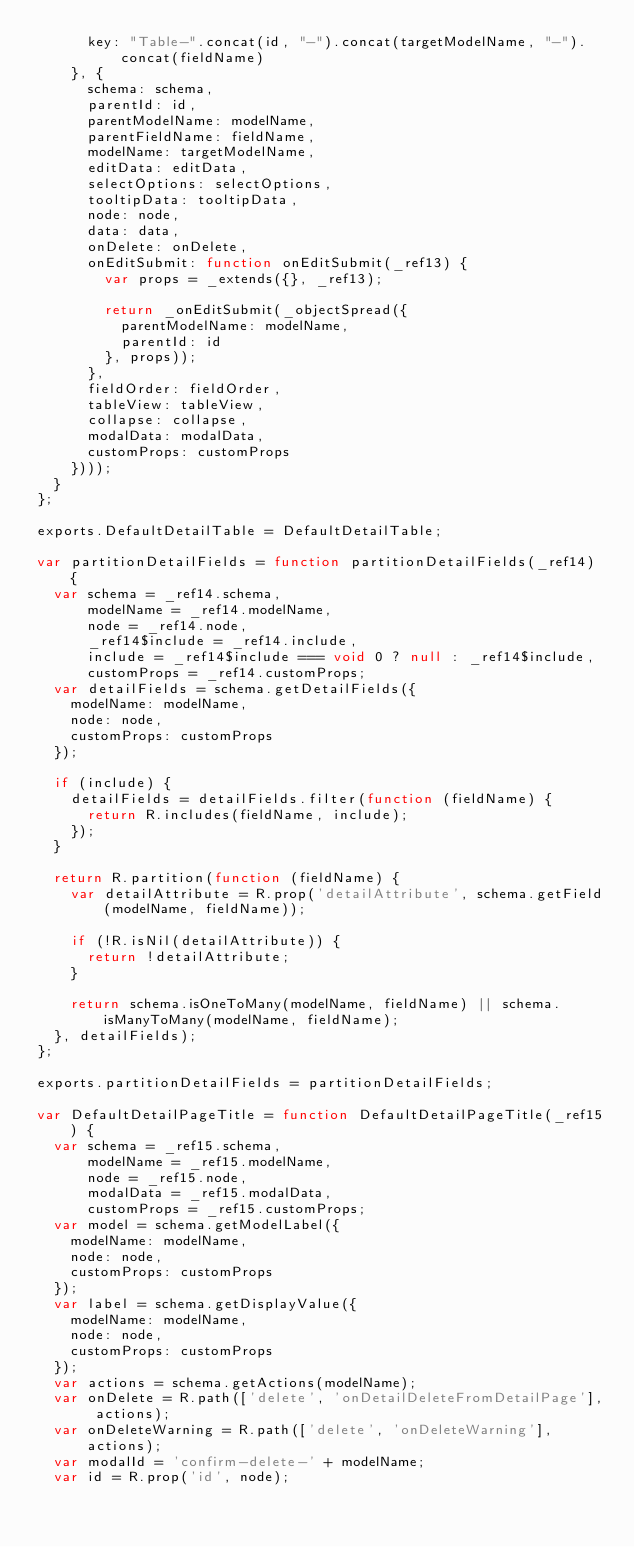Convert code to text. <code><loc_0><loc_0><loc_500><loc_500><_JavaScript_>      key: "Table-".concat(id, "-").concat(targetModelName, "-").concat(fieldName)
    }, {
      schema: schema,
      parentId: id,
      parentModelName: modelName,
      parentFieldName: fieldName,
      modelName: targetModelName,
      editData: editData,
      selectOptions: selectOptions,
      tooltipData: tooltipData,
      node: node,
      data: data,
      onDelete: onDelete,
      onEditSubmit: function onEditSubmit(_ref13) {
        var props = _extends({}, _ref13);

        return _onEditSubmit(_objectSpread({
          parentModelName: modelName,
          parentId: id
        }, props));
      },
      fieldOrder: fieldOrder,
      tableView: tableView,
      collapse: collapse,
      modalData: modalData,
      customProps: customProps
    })));
  }
};

exports.DefaultDetailTable = DefaultDetailTable;

var partitionDetailFields = function partitionDetailFields(_ref14) {
  var schema = _ref14.schema,
      modelName = _ref14.modelName,
      node = _ref14.node,
      _ref14$include = _ref14.include,
      include = _ref14$include === void 0 ? null : _ref14$include,
      customProps = _ref14.customProps;
  var detailFields = schema.getDetailFields({
    modelName: modelName,
    node: node,
    customProps: customProps
  });

  if (include) {
    detailFields = detailFields.filter(function (fieldName) {
      return R.includes(fieldName, include);
    });
  }

  return R.partition(function (fieldName) {
    var detailAttribute = R.prop('detailAttribute', schema.getField(modelName, fieldName));

    if (!R.isNil(detailAttribute)) {
      return !detailAttribute;
    }

    return schema.isOneToMany(modelName, fieldName) || schema.isManyToMany(modelName, fieldName);
  }, detailFields);
};

exports.partitionDetailFields = partitionDetailFields;

var DefaultDetailPageTitle = function DefaultDetailPageTitle(_ref15) {
  var schema = _ref15.schema,
      modelName = _ref15.modelName,
      node = _ref15.node,
      modalData = _ref15.modalData,
      customProps = _ref15.customProps;
  var model = schema.getModelLabel({
    modelName: modelName,
    node: node,
    customProps: customProps
  });
  var label = schema.getDisplayValue({
    modelName: modelName,
    node: node,
    customProps: customProps
  });
  var actions = schema.getActions(modelName);
  var onDelete = R.path(['delete', 'onDetailDeleteFromDetailPage'], actions);
  var onDeleteWarning = R.path(['delete', 'onDeleteWarning'], actions);
  var modalId = 'confirm-delete-' + modelName;
  var id = R.prop('id', node);</code> 